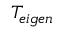Convert formula to latex. <formula><loc_0><loc_0><loc_500><loc_500>T _ { e i g e n }</formula> 